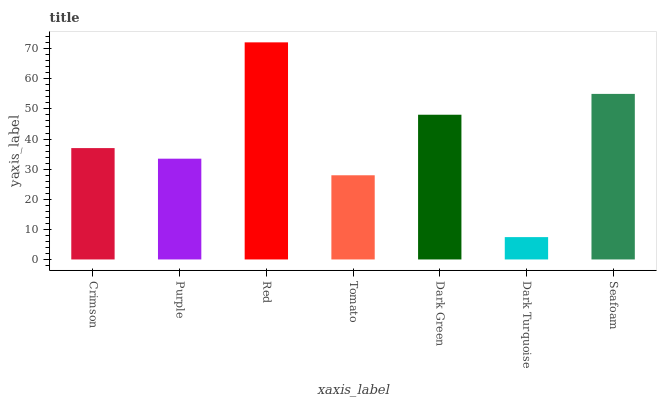Is Dark Turquoise the minimum?
Answer yes or no. Yes. Is Red the maximum?
Answer yes or no. Yes. Is Purple the minimum?
Answer yes or no. No. Is Purple the maximum?
Answer yes or no. No. Is Crimson greater than Purple?
Answer yes or no. Yes. Is Purple less than Crimson?
Answer yes or no. Yes. Is Purple greater than Crimson?
Answer yes or no. No. Is Crimson less than Purple?
Answer yes or no. No. Is Crimson the high median?
Answer yes or no. Yes. Is Crimson the low median?
Answer yes or no. Yes. Is Dark Turquoise the high median?
Answer yes or no. No. Is Dark Green the low median?
Answer yes or no. No. 